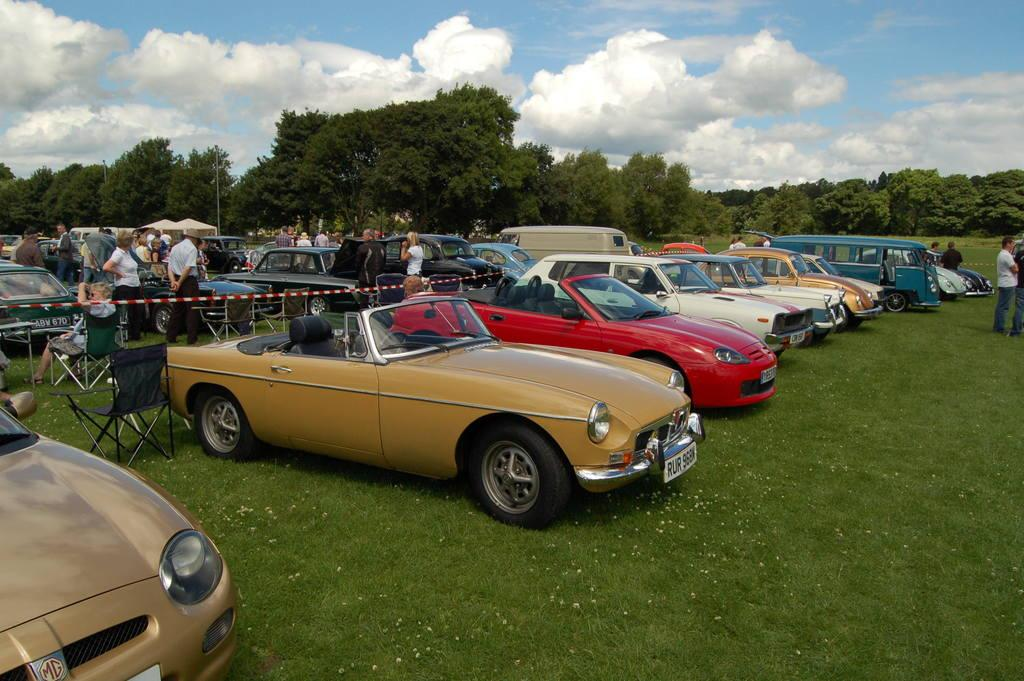What can be seen in the image related to transportation? There are vehicles in the image. Can you describe the appearance of the vehicles? The vehicles have different colors. What else is present in the image besides vehicles? There are trees and people in the image. What are some people doing in the image? Some people are sitting on chairs. How is the sky depicted in the image? The sky is in white and blue color. Can you tell me what your aunt discovered while sitting on a chair in the image? There is no aunt present in the image, nor is there any discovery mentioned or implied. 